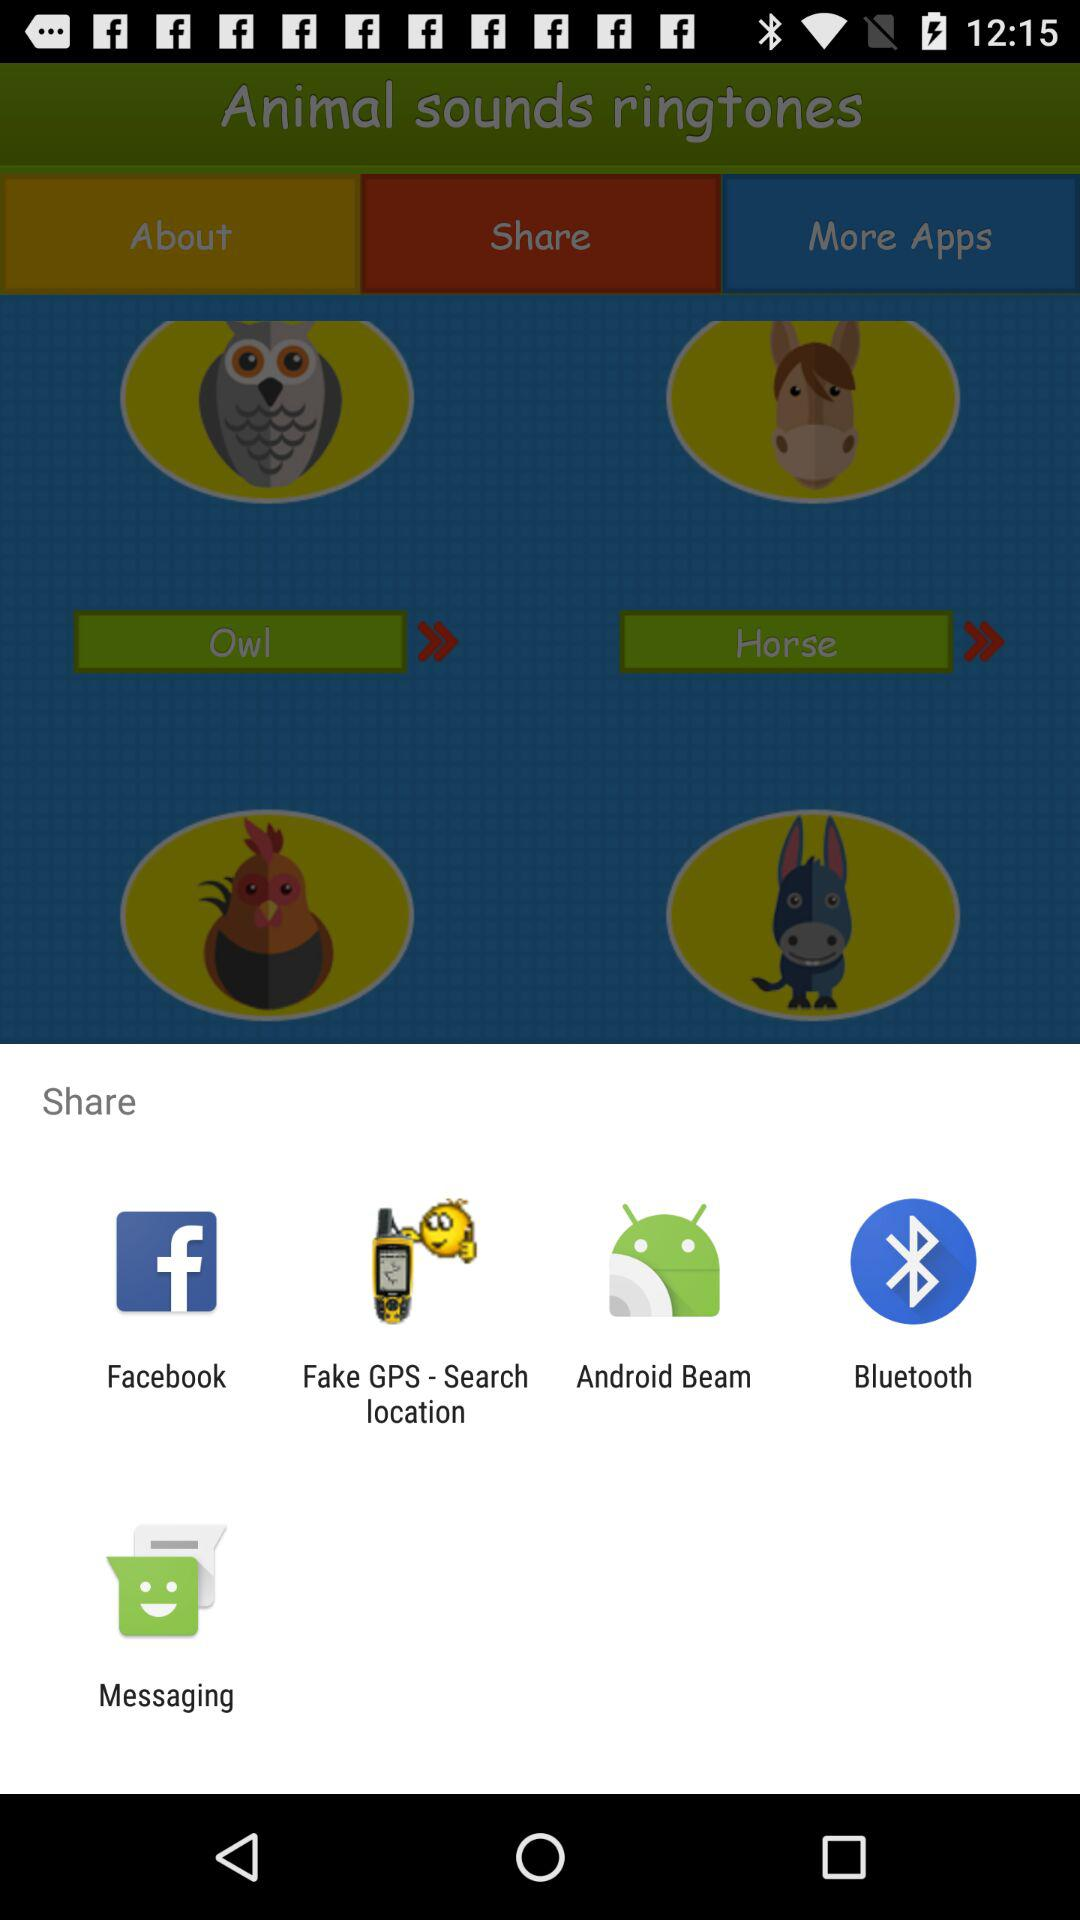Which applications can we use to share? The applications you can use to share are "Facebook", "Fake GPS - Search location", "Android Beam", "Bluetooth" and "Messaging". 